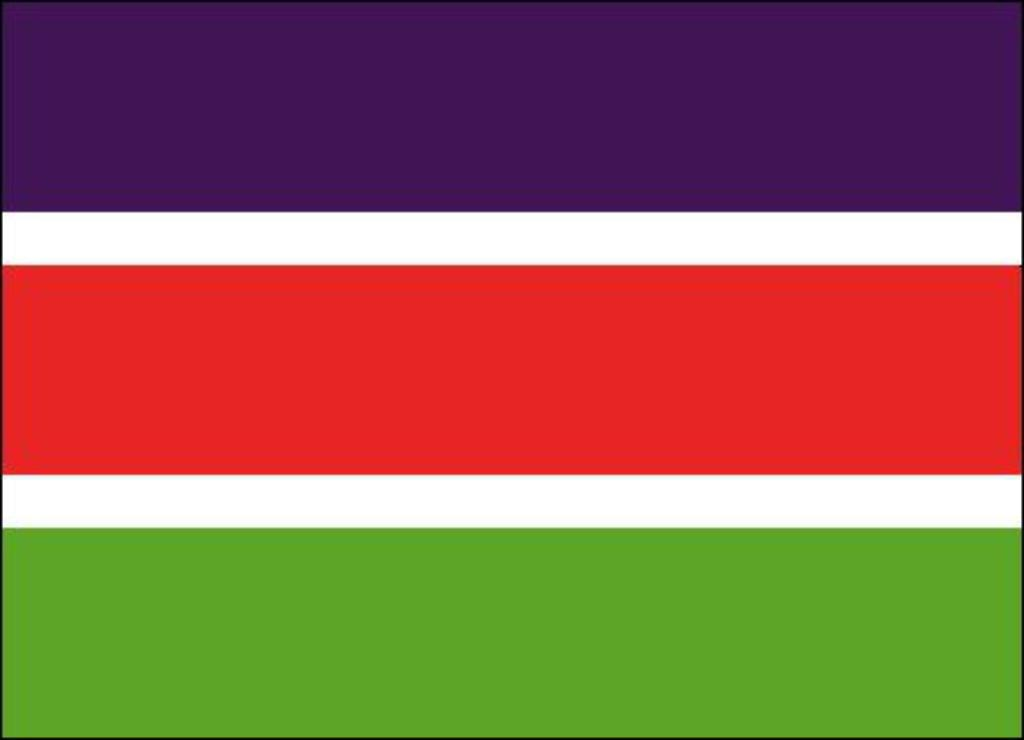What colors are present in the image? The image contains the colors purple, white, red, and green. Can you describe the color scheme of the image? The image features a combination of purple, white, red, and green. What type of guitar can be seen in the image? There is no guitar present in the image. What kind of soap is used to clean the apparatus in the image? There is no apparatus or soap present in the image. 